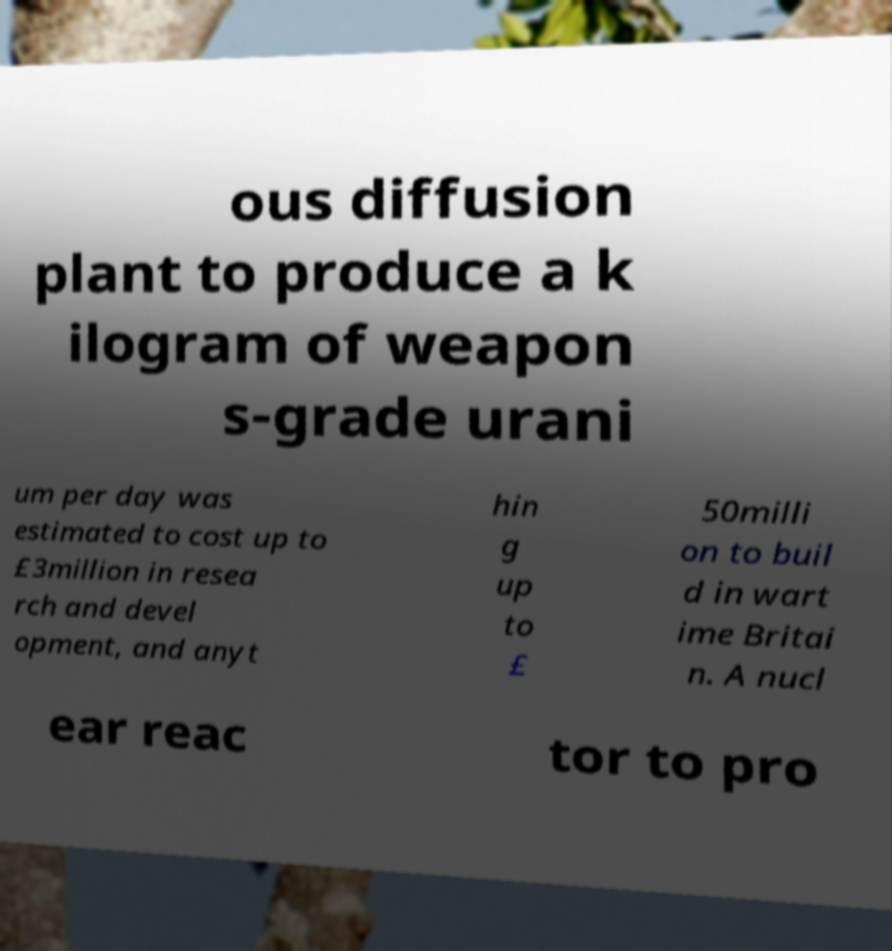Please identify and transcribe the text found in this image. ous diffusion plant to produce a k ilogram of weapon s-grade urani um per day was estimated to cost up to £3million in resea rch and devel opment, and anyt hin g up to £ 50milli on to buil d in wart ime Britai n. A nucl ear reac tor to pro 